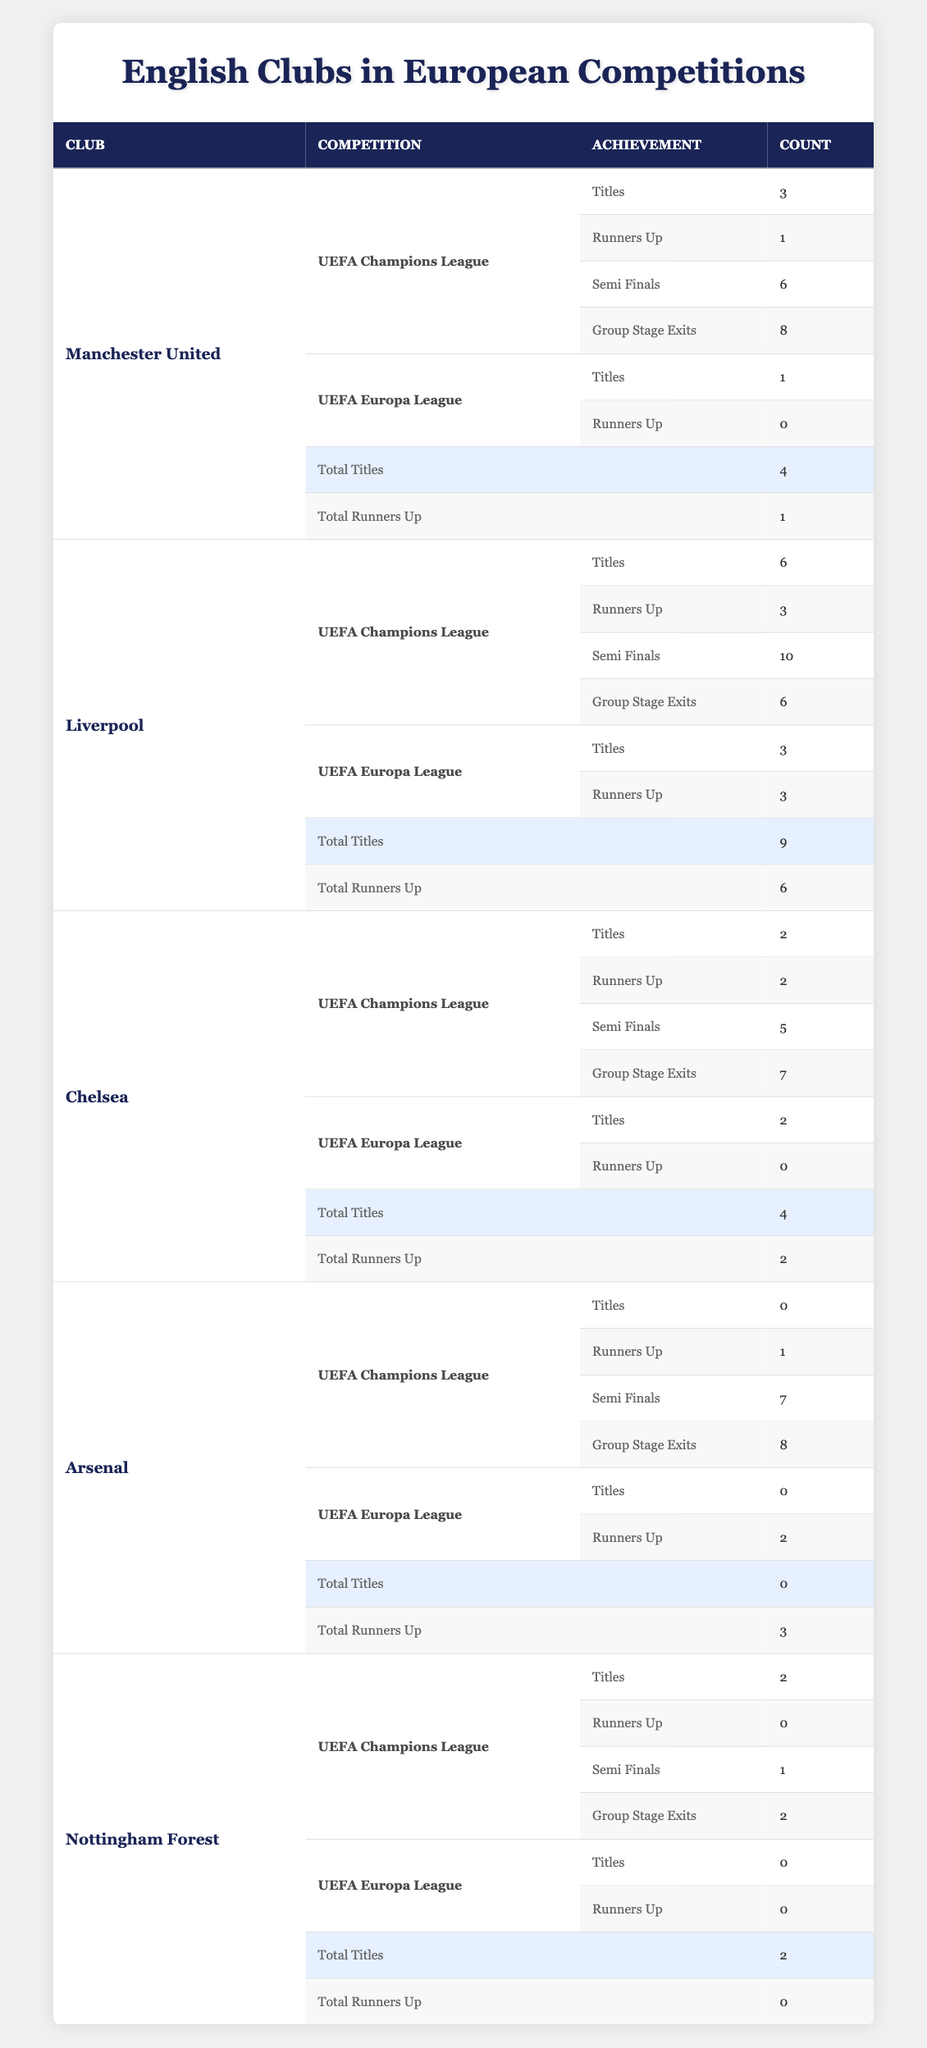What is the total number of UEFA Champions League titles won by Liverpool? Liverpool won 6 titles in the UEFA Champions League, which is stated in the table under "Titles."
Answer: 6 How many UEFA Europa League titles have Chelsea won? Chelsea has won 2 titles in the UEFA Europa League, as mentioned in the table.
Answer: 2 Which club has the most total titles across both the UEFA Champions League and UEFA Europa League? To find the club with the most total titles, we add up their titles: Liverpool (9), Manchester United (4), Chelsea (4), Nottingham Forest (2), and Arsenal (0). Liverpool has the highest total, with 9 titles.
Answer: Liverpool Did Arsenal ever win a title in either the UEFA Champions League or UEFA Europa League? Arsenal has not won any titles in both competitions; in the table, it shows 0 titles for both the UEFA Champions League and UEFA Europa League.
Answer: No What is the difference in the number of UEFA Champions League titles between Manchester United and Nottingham Forest? Manchester United has won 3 UEFA Champions League titles, while Nottingham Forest has won 2. The difference is calculated as 3 - 2 = 1.
Answer: 1 How many UEFA Champions League semi-finals has Arsenal reached? The table shows that Arsenal has reached the semi-finals 7 times in the UEFA Champions League, which is clearly listed under "Semi Finals."
Answer: 7 Which club has the highest number of group stage exits in the UEFA Champions League? Looking at the table, Manchester United has 8 group stage exits, which is more than any other club listed.
Answer: Manchester United If you combine Nottingham Forest and Arsenal's total titles in both competitions, what is the total? Nottingham Forest has 2 titles (Champions League), and Arsenal has 0 titles in both competitions. Adding these together gives a total of 2 + 0 = 2.
Answer: 2 How many clubs have more than 1 UEFA Europa League title? Only Liverpool and Chelsea have more than 1 UEFA Europa League title (3 and 2 respectively). Thus, there are 2 clubs that fulfill this condition.
Answer: 2 